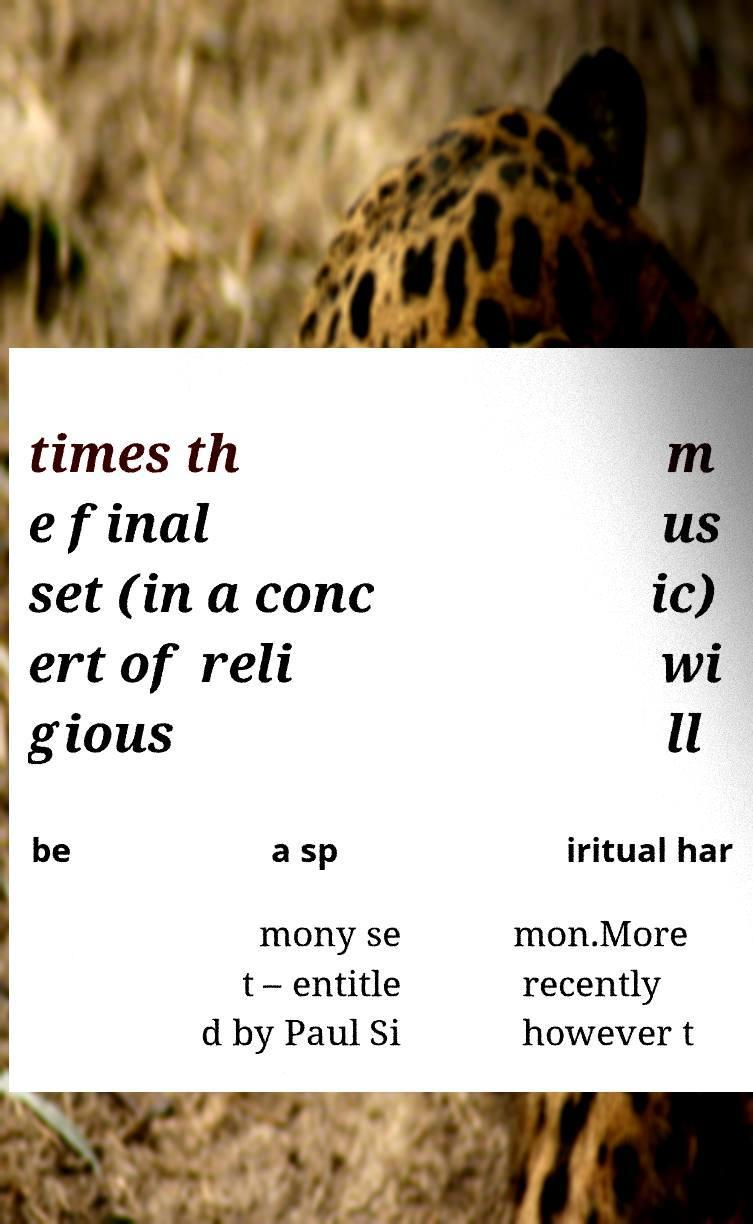Could you extract and type out the text from this image? times th e final set (in a conc ert of reli gious m us ic) wi ll be a sp iritual har mony se t – entitle d by Paul Si mon.More recently however t 